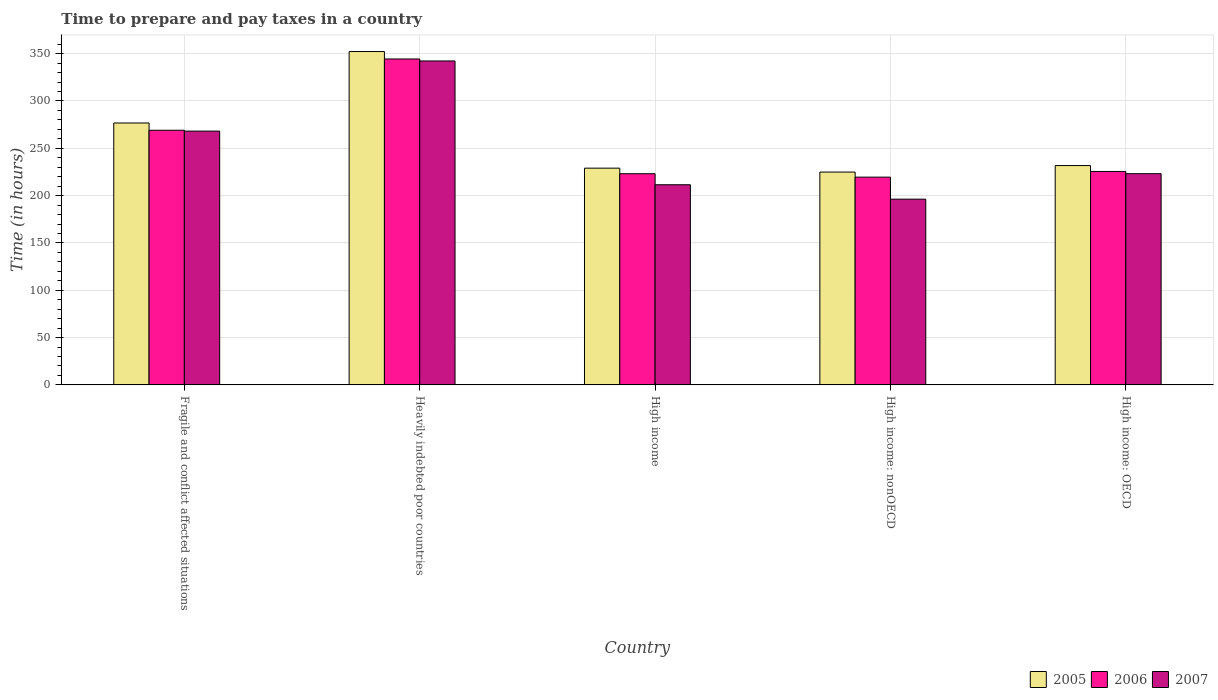Are the number of bars per tick equal to the number of legend labels?
Provide a succinct answer. Yes. What is the label of the 2nd group of bars from the left?
Make the answer very short. Heavily indebted poor countries. What is the number of hours required to prepare and pay taxes in 2006 in High income: OECD?
Ensure brevity in your answer.  225.53. Across all countries, what is the maximum number of hours required to prepare and pay taxes in 2005?
Give a very brief answer. 352.24. Across all countries, what is the minimum number of hours required to prepare and pay taxes in 2006?
Offer a terse response. 219.55. In which country was the number of hours required to prepare and pay taxes in 2005 maximum?
Provide a short and direct response. Heavily indebted poor countries. In which country was the number of hours required to prepare and pay taxes in 2005 minimum?
Provide a short and direct response. High income: nonOECD. What is the total number of hours required to prepare and pay taxes in 2006 in the graph?
Provide a succinct answer. 1281.69. What is the difference between the number of hours required to prepare and pay taxes in 2006 in High income: OECD and that in High income: nonOECD?
Your answer should be compact. 5.98. What is the difference between the number of hours required to prepare and pay taxes in 2005 in High income and the number of hours required to prepare and pay taxes in 2007 in High income: nonOECD?
Your answer should be compact. 32.78. What is the average number of hours required to prepare and pay taxes in 2005 per country?
Make the answer very short. 262.94. What is the difference between the number of hours required to prepare and pay taxes of/in 2006 and number of hours required to prepare and pay taxes of/in 2005 in High income: OECD?
Provide a succinct answer. -6.23. What is the ratio of the number of hours required to prepare and pay taxes in 2006 in Fragile and conflict affected situations to that in Heavily indebted poor countries?
Keep it short and to the point. 0.78. What is the difference between the highest and the second highest number of hours required to prepare and pay taxes in 2006?
Keep it short and to the point. 118.86. What is the difference between the highest and the lowest number of hours required to prepare and pay taxes in 2005?
Offer a very short reply. 127.35. In how many countries, is the number of hours required to prepare and pay taxes in 2006 greater than the average number of hours required to prepare and pay taxes in 2006 taken over all countries?
Provide a short and direct response. 2. Is the sum of the number of hours required to prepare and pay taxes in 2005 in Heavily indebted poor countries and High income greater than the maximum number of hours required to prepare and pay taxes in 2007 across all countries?
Your answer should be compact. Yes. What does the 2nd bar from the left in High income: OECD represents?
Your answer should be very brief. 2006. What does the 3rd bar from the right in Fragile and conflict affected situations represents?
Make the answer very short. 2005. Is it the case that in every country, the sum of the number of hours required to prepare and pay taxes in 2005 and number of hours required to prepare and pay taxes in 2006 is greater than the number of hours required to prepare and pay taxes in 2007?
Give a very brief answer. Yes. How many countries are there in the graph?
Your answer should be very brief. 5. Are the values on the major ticks of Y-axis written in scientific E-notation?
Keep it short and to the point. No. Does the graph contain any zero values?
Keep it short and to the point. No. Does the graph contain grids?
Ensure brevity in your answer.  Yes. Where does the legend appear in the graph?
Keep it short and to the point. Bottom right. What is the title of the graph?
Your answer should be very brief. Time to prepare and pay taxes in a country. What is the label or title of the Y-axis?
Provide a short and direct response. Time (in hours). What is the Time (in hours) of 2005 in Fragile and conflict affected situations?
Offer a terse response. 276.75. What is the Time (in hours) of 2006 in Fragile and conflict affected situations?
Give a very brief answer. 269.07. What is the Time (in hours) of 2007 in Fragile and conflict affected situations?
Your answer should be compact. 268.17. What is the Time (in hours) in 2005 in Heavily indebted poor countries?
Provide a short and direct response. 352.24. What is the Time (in hours) in 2006 in Heavily indebted poor countries?
Provide a succinct answer. 344.39. What is the Time (in hours) of 2007 in Heavily indebted poor countries?
Provide a short and direct response. 342.29. What is the Time (in hours) in 2005 in High income?
Provide a succinct answer. 229.04. What is the Time (in hours) in 2006 in High income?
Your answer should be compact. 223.14. What is the Time (in hours) in 2007 in High income?
Provide a succinct answer. 211.51. What is the Time (in hours) of 2005 in High income: nonOECD?
Make the answer very short. 224.89. What is the Time (in hours) of 2006 in High income: nonOECD?
Make the answer very short. 219.55. What is the Time (in hours) in 2007 in High income: nonOECD?
Offer a very short reply. 196.26. What is the Time (in hours) of 2005 in High income: OECD?
Ensure brevity in your answer.  231.76. What is the Time (in hours) of 2006 in High income: OECD?
Make the answer very short. 225.53. What is the Time (in hours) in 2007 in High income: OECD?
Give a very brief answer. 223.2. Across all countries, what is the maximum Time (in hours) in 2005?
Keep it short and to the point. 352.24. Across all countries, what is the maximum Time (in hours) in 2006?
Provide a succinct answer. 344.39. Across all countries, what is the maximum Time (in hours) of 2007?
Offer a terse response. 342.29. Across all countries, what is the minimum Time (in hours) in 2005?
Your response must be concise. 224.89. Across all countries, what is the minimum Time (in hours) in 2006?
Ensure brevity in your answer.  219.55. Across all countries, what is the minimum Time (in hours) of 2007?
Your response must be concise. 196.26. What is the total Time (in hours) in 2005 in the graph?
Your answer should be compact. 1314.69. What is the total Time (in hours) of 2006 in the graph?
Keep it short and to the point. 1281.69. What is the total Time (in hours) in 2007 in the graph?
Your answer should be very brief. 1241.43. What is the difference between the Time (in hours) in 2005 in Fragile and conflict affected situations and that in Heavily indebted poor countries?
Your answer should be very brief. -75.49. What is the difference between the Time (in hours) of 2006 in Fragile and conflict affected situations and that in Heavily indebted poor countries?
Make the answer very short. -75.33. What is the difference between the Time (in hours) in 2007 in Fragile and conflict affected situations and that in Heavily indebted poor countries?
Your answer should be very brief. -74.12. What is the difference between the Time (in hours) of 2005 in Fragile and conflict affected situations and that in High income?
Ensure brevity in your answer.  47.71. What is the difference between the Time (in hours) of 2006 in Fragile and conflict affected situations and that in High income?
Offer a very short reply. 45.93. What is the difference between the Time (in hours) of 2007 in Fragile and conflict affected situations and that in High income?
Your response must be concise. 56.66. What is the difference between the Time (in hours) of 2005 in Fragile and conflict affected situations and that in High income: nonOECD?
Make the answer very short. 51.86. What is the difference between the Time (in hours) in 2006 in Fragile and conflict affected situations and that in High income: nonOECD?
Offer a terse response. 49.52. What is the difference between the Time (in hours) of 2007 in Fragile and conflict affected situations and that in High income: nonOECD?
Your answer should be very brief. 71.91. What is the difference between the Time (in hours) of 2005 in Fragile and conflict affected situations and that in High income: OECD?
Make the answer very short. 44.99. What is the difference between the Time (in hours) of 2006 in Fragile and conflict affected situations and that in High income: OECD?
Your answer should be compact. 43.54. What is the difference between the Time (in hours) in 2007 in Fragile and conflict affected situations and that in High income: OECD?
Give a very brief answer. 44.97. What is the difference between the Time (in hours) of 2005 in Heavily indebted poor countries and that in High income?
Keep it short and to the point. 123.2. What is the difference between the Time (in hours) of 2006 in Heavily indebted poor countries and that in High income?
Your answer should be compact. 121.25. What is the difference between the Time (in hours) of 2007 in Heavily indebted poor countries and that in High income?
Provide a succinct answer. 130.78. What is the difference between the Time (in hours) in 2005 in Heavily indebted poor countries and that in High income: nonOECD?
Ensure brevity in your answer.  127.35. What is the difference between the Time (in hours) of 2006 in Heavily indebted poor countries and that in High income: nonOECD?
Your answer should be very brief. 124.84. What is the difference between the Time (in hours) in 2007 in Heavily indebted poor countries and that in High income: nonOECD?
Ensure brevity in your answer.  146.03. What is the difference between the Time (in hours) in 2005 in Heavily indebted poor countries and that in High income: OECD?
Provide a succinct answer. 120.48. What is the difference between the Time (in hours) of 2006 in Heavily indebted poor countries and that in High income: OECD?
Provide a short and direct response. 118.86. What is the difference between the Time (in hours) of 2007 in Heavily indebted poor countries and that in High income: OECD?
Your answer should be compact. 119.09. What is the difference between the Time (in hours) of 2005 in High income and that in High income: nonOECD?
Provide a succinct answer. 4.15. What is the difference between the Time (in hours) of 2006 in High income and that in High income: nonOECD?
Make the answer very short. 3.59. What is the difference between the Time (in hours) of 2007 in High income and that in High income: nonOECD?
Your response must be concise. 15.25. What is the difference between the Time (in hours) of 2005 in High income and that in High income: OECD?
Make the answer very short. -2.72. What is the difference between the Time (in hours) in 2006 in High income and that in High income: OECD?
Give a very brief answer. -2.39. What is the difference between the Time (in hours) in 2007 in High income and that in High income: OECD?
Your response must be concise. -11.69. What is the difference between the Time (in hours) of 2005 in High income: nonOECD and that in High income: OECD?
Provide a short and direct response. -6.86. What is the difference between the Time (in hours) of 2006 in High income: nonOECD and that in High income: OECD?
Your answer should be compact. -5.98. What is the difference between the Time (in hours) in 2007 in High income: nonOECD and that in High income: OECD?
Offer a very short reply. -26.94. What is the difference between the Time (in hours) in 2005 in Fragile and conflict affected situations and the Time (in hours) in 2006 in Heavily indebted poor countries?
Offer a terse response. -67.64. What is the difference between the Time (in hours) of 2005 in Fragile and conflict affected situations and the Time (in hours) of 2007 in Heavily indebted poor countries?
Your answer should be compact. -65.54. What is the difference between the Time (in hours) of 2006 in Fragile and conflict affected situations and the Time (in hours) of 2007 in Heavily indebted poor countries?
Offer a very short reply. -73.22. What is the difference between the Time (in hours) in 2005 in Fragile and conflict affected situations and the Time (in hours) in 2006 in High income?
Ensure brevity in your answer.  53.61. What is the difference between the Time (in hours) of 2005 in Fragile and conflict affected situations and the Time (in hours) of 2007 in High income?
Offer a very short reply. 65.24. What is the difference between the Time (in hours) of 2006 in Fragile and conflict affected situations and the Time (in hours) of 2007 in High income?
Offer a very short reply. 57.56. What is the difference between the Time (in hours) of 2005 in Fragile and conflict affected situations and the Time (in hours) of 2006 in High income: nonOECD?
Keep it short and to the point. 57.2. What is the difference between the Time (in hours) in 2005 in Fragile and conflict affected situations and the Time (in hours) in 2007 in High income: nonOECD?
Provide a short and direct response. 80.49. What is the difference between the Time (in hours) of 2006 in Fragile and conflict affected situations and the Time (in hours) of 2007 in High income: nonOECD?
Offer a very short reply. 72.81. What is the difference between the Time (in hours) in 2005 in Fragile and conflict affected situations and the Time (in hours) in 2006 in High income: OECD?
Offer a very short reply. 51.22. What is the difference between the Time (in hours) in 2005 in Fragile and conflict affected situations and the Time (in hours) in 2007 in High income: OECD?
Provide a succinct answer. 53.55. What is the difference between the Time (in hours) of 2006 in Fragile and conflict affected situations and the Time (in hours) of 2007 in High income: OECD?
Ensure brevity in your answer.  45.87. What is the difference between the Time (in hours) of 2005 in Heavily indebted poor countries and the Time (in hours) of 2006 in High income?
Offer a very short reply. 129.1. What is the difference between the Time (in hours) of 2005 in Heavily indebted poor countries and the Time (in hours) of 2007 in High income?
Make the answer very short. 140.73. What is the difference between the Time (in hours) of 2006 in Heavily indebted poor countries and the Time (in hours) of 2007 in High income?
Offer a terse response. 132.89. What is the difference between the Time (in hours) of 2005 in Heavily indebted poor countries and the Time (in hours) of 2006 in High income: nonOECD?
Your answer should be very brief. 132.69. What is the difference between the Time (in hours) of 2005 in Heavily indebted poor countries and the Time (in hours) of 2007 in High income: nonOECD?
Your answer should be very brief. 155.98. What is the difference between the Time (in hours) of 2006 in Heavily indebted poor countries and the Time (in hours) of 2007 in High income: nonOECD?
Your response must be concise. 148.13. What is the difference between the Time (in hours) in 2005 in Heavily indebted poor countries and the Time (in hours) in 2006 in High income: OECD?
Keep it short and to the point. 126.71. What is the difference between the Time (in hours) in 2005 in Heavily indebted poor countries and the Time (in hours) in 2007 in High income: OECD?
Offer a terse response. 129.04. What is the difference between the Time (in hours) in 2006 in Heavily indebted poor countries and the Time (in hours) in 2007 in High income: OECD?
Your answer should be very brief. 121.19. What is the difference between the Time (in hours) in 2005 in High income and the Time (in hours) in 2006 in High income: nonOECD?
Your answer should be very brief. 9.49. What is the difference between the Time (in hours) of 2005 in High income and the Time (in hours) of 2007 in High income: nonOECD?
Offer a terse response. 32.78. What is the difference between the Time (in hours) in 2006 in High income and the Time (in hours) in 2007 in High income: nonOECD?
Keep it short and to the point. 26.88. What is the difference between the Time (in hours) of 2005 in High income and the Time (in hours) of 2006 in High income: OECD?
Your response must be concise. 3.51. What is the difference between the Time (in hours) in 2005 in High income and the Time (in hours) in 2007 in High income: OECD?
Provide a succinct answer. 5.84. What is the difference between the Time (in hours) of 2006 in High income and the Time (in hours) of 2007 in High income: OECD?
Provide a succinct answer. -0.06. What is the difference between the Time (in hours) in 2005 in High income: nonOECD and the Time (in hours) in 2006 in High income: OECD?
Offer a very short reply. -0.64. What is the difference between the Time (in hours) of 2005 in High income: nonOECD and the Time (in hours) of 2007 in High income: OECD?
Provide a succinct answer. 1.69. What is the difference between the Time (in hours) of 2006 in High income: nonOECD and the Time (in hours) of 2007 in High income: OECD?
Provide a short and direct response. -3.65. What is the average Time (in hours) in 2005 per country?
Your answer should be compact. 262.94. What is the average Time (in hours) in 2006 per country?
Ensure brevity in your answer.  256.34. What is the average Time (in hours) in 2007 per country?
Your answer should be compact. 248.29. What is the difference between the Time (in hours) of 2005 and Time (in hours) of 2006 in Fragile and conflict affected situations?
Make the answer very short. 7.68. What is the difference between the Time (in hours) of 2005 and Time (in hours) of 2007 in Fragile and conflict affected situations?
Offer a terse response. 8.58. What is the difference between the Time (in hours) in 2006 and Time (in hours) in 2007 in Fragile and conflict affected situations?
Your answer should be very brief. 0.9. What is the difference between the Time (in hours) in 2005 and Time (in hours) in 2006 in Heavily indebted poor countries?
Provide a short and direct response. 7.85. What is the difference between the Time (in hours) of 2005 and Time (in hours) of 2007 in Heavily indebted poor countries?
Your answer should be compact. 9.95. What is the difference between the Time (in hours) in 2006 and Time (in hours) in 2007 in Heavily indebted poor countries?
Offer a very short reply. 2.11. What is the difference between the Time (in hours) of 2005 and Time (in hours) of 2006 in High income?
Make the answer very short. 5.9. What is the difference between the Time (in hours) of 2005 and Time (in hours) of 2007 in High income?
Make the answer very short. 17.53. What is the difference between the Time (in hours) in 2006 and Time (in hours) in 2007 in High income?
Offer a terse response. 11.63. What is the difference between the Time (in hours) of 2005 and Time (in hours) of 2006 in High income: nonOECD?
Your answer should be compact. 5.34. What is the difference between the Time (in hours) of 2005 and Time (in hours) of 2007 in High income: nonOECD?
Your response must be concise. 28.63. What is the difference between the Time (in hours) in 2006 and Time (in hours) in 2007 in High income: nonOECD?
Your answer should be compact. 23.29. What is the difference between the Time (in hours) in 2005 and Time (in hours) in 2006 in High income: OECD?
Your answer should be very brief. 6.23. What is the difference between the Time (in hours) in 2005 and Time (in hours) in 2007 in High income: OECD?
Provide a succinct answer. 8.56. What is the difference between the Time (in hours) in 2006 and Time (in hours) in 2007 in High income: OECD?
Offer a terse response. 2.33. What is the ratio of the Time (in hours) of 2005 in Fragile and conflict affected situations to that in Heavily indebted poor countries?
Your answer should be very brief. 0.79. What is the ratio of the Time (in hours) of 2006 in Fragile and conflict affected situations to that in Heavily indebted poor countries?
Ensure brevity in your answer.  0.78. What is the ratio of the Time (in hours) of 2007 in Fragile and conflict affected situations to that in Heavily indebted poor countries?
Make the answer very short. 0.78. What is the ratio of the Time (in hours) in 2005 in Fragile and conflict affected situations to that in High income?
Ensure brevity in your answer.  1.21. What is the ratio of the Time (in hours) of 2006 in Fragile and conflict affected situations to that in High income?
Give a very brief answer. 1.21. What is the ratio of the Time (in hours) in 2007 in Fragile and conflict affected situations to that in High income?
Offer a very short reply. 1.27. What is the ratio of the Time (in hours) of 2005 in Fragile and conflict affected situations to that in High income: nonOECD?
Your answer should be very brief. 1.23. What is the ratio of the Time (in hours) of 2006 in Fragile and conflict affected situations to that in High income: nonOECD?
Make the answer very short. 1.23. What is the ratio of the Time (in hours) of 2007 in Fragile and conflict affected situations to that in High income: nonOECD?
Your answer should be compact. 1.37. What is the ratio of the Time (in hours) in 2005 in Fragile and conflict affected situations to that in High income: OECD?
Offer a very short reply. 1.19. What is the ratio of the Time (in hours) of 2006 in Fragile and conflict affected situations to that in High income: OECD?
Give a very brief answer. 1.19. What is the ratio of the Time (in hours) of 2007 in Fragile and conflict affected situations to that in High income: OECD?
Provide a short and direct response. 1.2. What is the ratio of the Time (in hours) of 2005 in Heavily indebted poor countries to that in High income?
Ensure brevity in your answer.  1.54. What is the ratio of the Time (in hours) in 2006 in Heavily indebted poor countries to that in High income?
Give a very brief answer. 1.54. What is the ratio of the Time (in hours) of 2007 in Heavily indebted poor countries to that in High income?
Provide a succinct answer. 1.62. What is the ratio of the Time (in hours) of 2005 in Heavily indebted poor countries to that in High income: nonOECD?
Your answer should be compact. 1.57. What is the ratio of the Time (in hours) in 2006 in Heavily indebted poor countries to that in High income: nonOECD?
Provide a succinct answer. 1.57. What is the ratio of the Time (in hours) of 2007 in Heavily indebted poor countries to that in High income: nonOECD?
Offer a very short reply. 1.74. What is the ratio of the Time (in hours) of 2005 in Heavily indebted poor countries to that in High income: OECD?
Make the answer very short. 1.52. What is the ratio of the Time (in hours) in 2006 in Heavily indebted poor countries to that in High income: OECD?
Provide a succinct answer. 1.53. What is the ratio of the Time (in hours) of 2007 in Heavily indebted poor countries to that in High income: OECD?
Offer a terse response. 1.53. What is the ratio of the Time (in hours) in 2005 in High income to that in High income: nonOECD?
Ensure brevity in your answer.  1.02. What is the ratio of the Time (in hours) of 2006 in High income to that in High income: nonOECD?
Give a very brief answer. 1.02. What is the ratio of the Time (in hours) of 2007 in High income to that in High income: nonOECD?
Offer a terse response. 1.08. What is the ratio of the Time (in hours) in 2005 in High income to that in High income: OECD?
Keep it short and to the point. 0.99. What is the ratio of the Time (in hours) of 2007 in High income to that in High income: OECD?
Keep it short and to the point. 0.95. What is the ratio of the Time (in hours) in 2005 in High income: nonOECD to that in High income: OECD?
Provide a succinct answer. 0.97. What is the ratio of the Time (in hours) in 2006 in High income: nonOECD to that in High income: OECD?
Provide a succinct answer. 0.97. What is the ratio of the Time (in hours) in 2007 in High income: nonOECD to that in High income: OECD?
Provide a short and direct response. 0.88. What is the difference between the highest and the second highest Time (in hours) in 2005?
Ensure brevity in your answer.  75.49. What is the difference between the highest and the second highest Time (in hours) in 2006?
Keep it short and to the point. 75.33. What is the difference between the highest and the second highest Time (in hours) in 2007?
Offer a very short reply. 74.12. What is the difference between the highest and the lowest Time (in hours) of 2005?
Ensure brevity in your answer.  127.35. What is the difference between the highest and the lowest Time (in hours) in 2006?
Your answer should be compact. 124.84. What is the difference between the highest and the lowest Time (in hours) of 2007?
Keep it short and to the point. 146.03. 